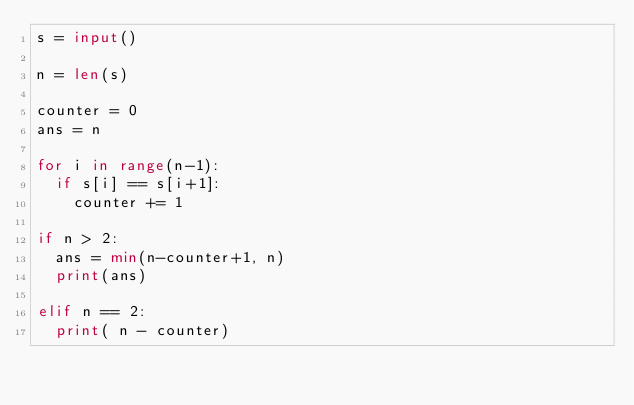<code> <loc_0><loc_0><loc_500><loc_500><_Python_>s = input()

n = len(s)
 
counter = 0
ans = n
 
for i in range(n-1):
  if s[i] == s[i+1]:
    counter += 1
    
if n > 2:
  ans = min(n-counter+1, n)
  print(ans)
  
elif n == 2:
  print( n - counter)</code> 